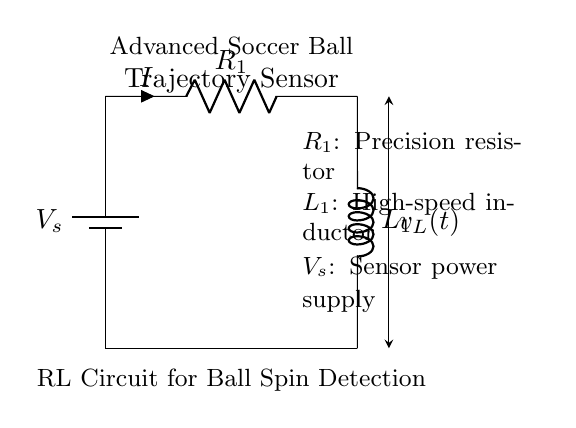What is the supply voltage in this circuit? The supply voltage, denoted as \( V_s \), is shown in the circuit diagram as the voltage source connected at the top. It provides power to the circuit.
Answer: Voltage source What does \( R_1 \) represent in the circuit? \( R_1 \) is labeled as a precision resistor in the diagram, indicating its role to provide stability and accuracy in the circuit performance involving the sensor.
Answer: Precision resistor What is the function of \( L_1 \)? \( L_1 \) is identified as a high-speed inductor, suggesting that it is used to control the current and voltage characteristics in response to the changing conditions of the sensor detecting the ball's spin.
Answer: High-speed inductor What type of circuit is this? The circuit consists of a resistor and an inductor connected in series, which classifies it as an RL circuit, commonly used for applications involving time-dependent signals and filtering.
Answer: RL circuit How can the inductor's voltage \( v_L(t) \) be interpreted? The voltage \( v_L(t) \) is indicated with a directional arrow suggesting it varies over time (t), related to the current's rate of change through the inductor, which influences its operational characteristics in the circuit.
Answer: Voltage over time What is the purpose of the advanced soccer ball trajectory sensor shown? The labeling of the sensor indicates it plays a crucial role in detecting and analyzing the trajectory and spin of the ball, likely utilizing the characteristics of the RL circuit for precise measurements.
Answer: Ball trajectory detection 